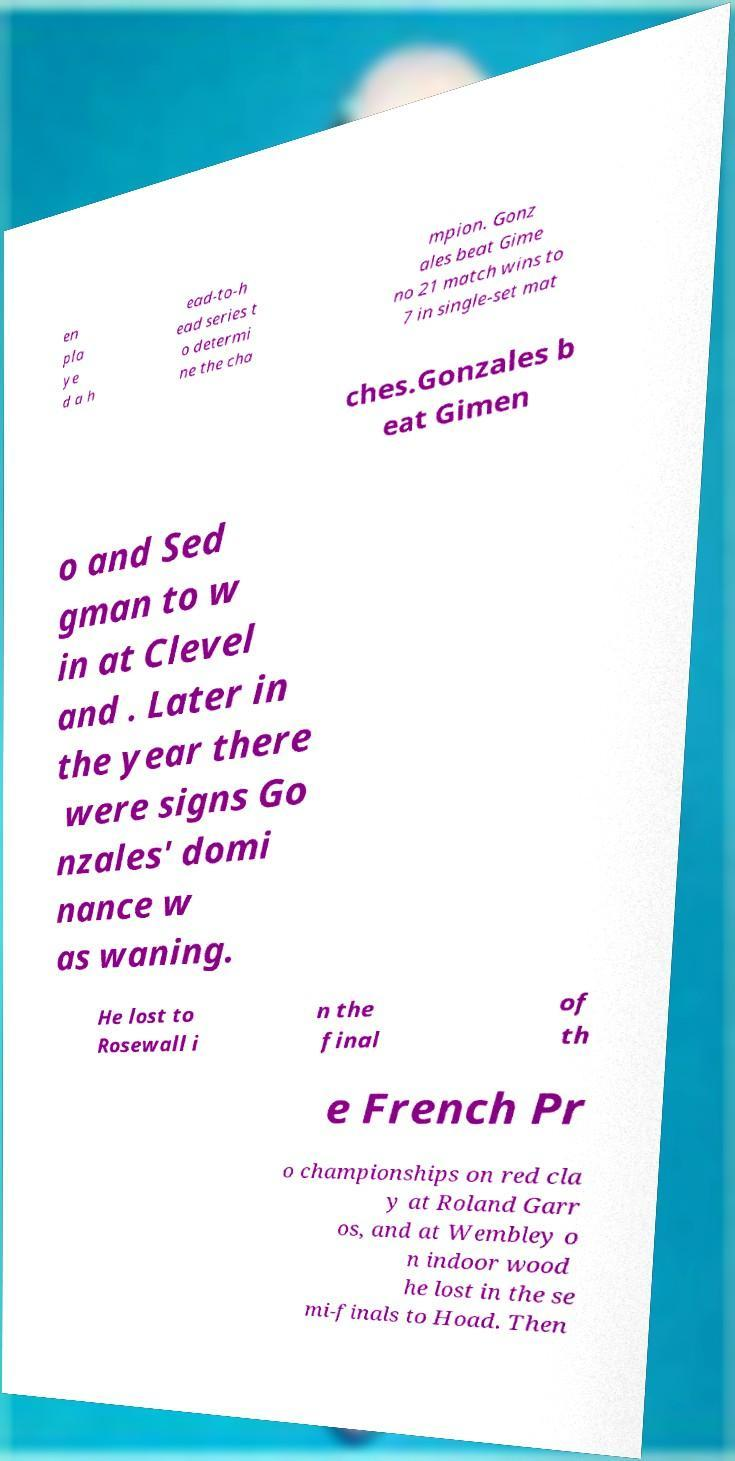Can you accurately transcribe the text from the provided image for me? en pla ye d a h ead-to-h ead series t o determi ne the cha mpion. Gonz ales beat Gime no 21 match wins to 7 in single-set mat ches.Gonzales b eat Gimen o and Sed gman to w in at Clevel and . Later in the year there were signs Go nzales' domi nance w as waning. He lost to Rosewall i n the final of th e French Pr o championships on red cla y at Roland Garr os, and at Wembley o n indoor wood he lost in the se mi-finals to Hoad. Then 